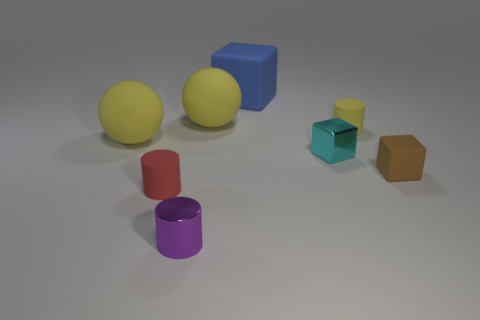Subtract all purple cylinders. Subtract all brown spheres. How many cylinders are left? 2 Add 1 large blue matte things. How many objects exist? 9 Subtract all cylinders. How many objects are left? 5 Subtract 0 cyan cylinders. How many objects are left? 8 Subtract all big red metallic objects. Subtract all tiny metallic blocks. How many objects are left? 7 Add 6 large rubber blocks. How many large rubber blocks are left? 7 Add 3 green cylinders. How many green cylinders exist? 3 